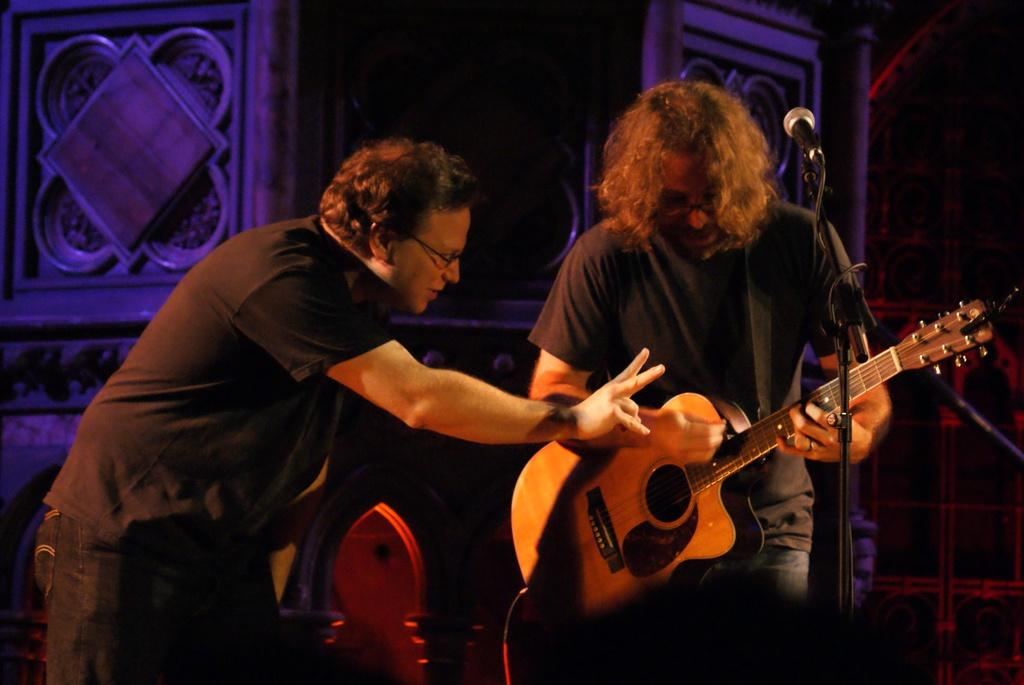How many people are in the image? There are two men in the image. What is the man wearing on the left side of the image? The man on the left side of the image is wearing a black t-shirt. What is the man in the black t-shirt doing? The man in the black t-shirt is playing a guitar. What object is present for amplifying sound in the image? There is a microphone with a mic holder in the image. What type of eggs can be seen cooking on the stove in the image? There are no eggs or stoves present in the image; it features two men, one of whom is playing a guitar. Is there a horse visible in the image? No, there is no horse present in the image. 